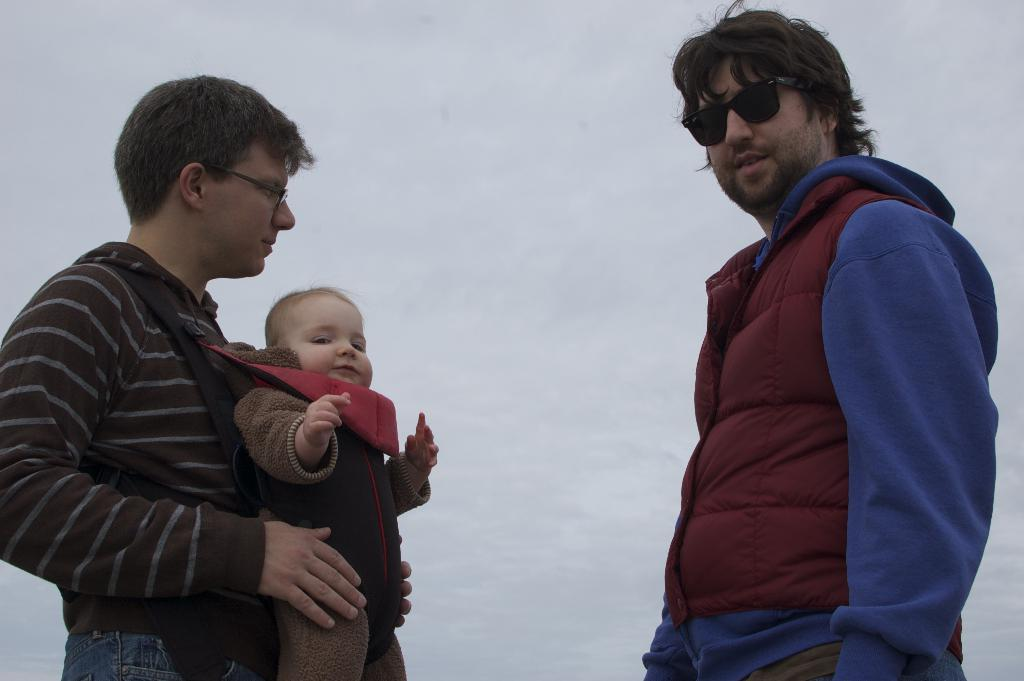How many people are in the image? There are two persons in the image. Can you describe one of the persons? One of the persons is a boy. What can be seen in the background of the image? There is snow in the background of the image. What type of bone can be seen in the image? There is no bone present in the image; it features two persons and snow in the background. How many babies are visible in the image? There are no babies visible in the image; it features two persons, one of whom is a boy. 